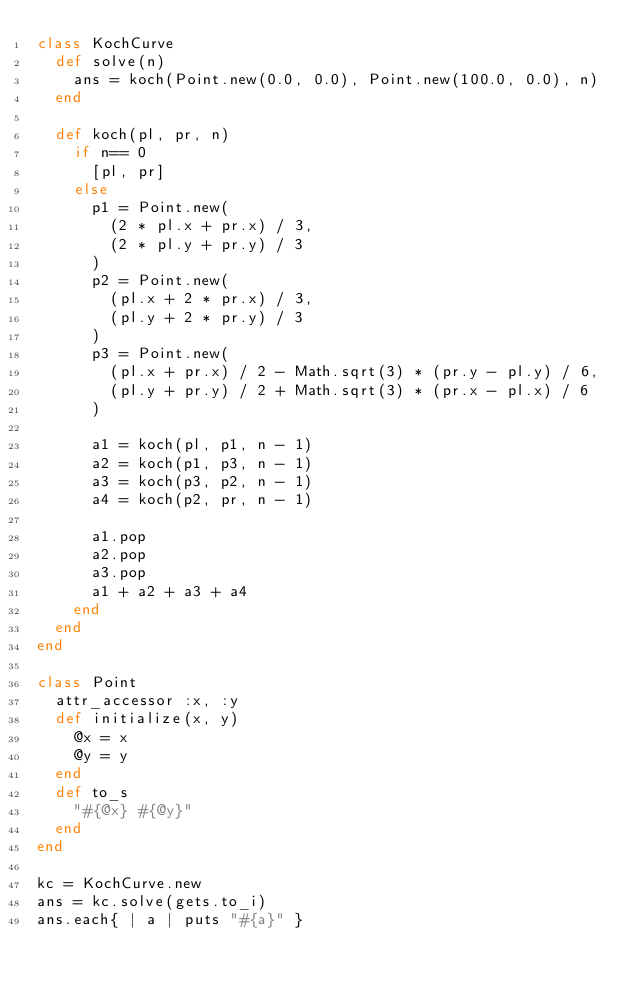Convert code to text. <code><loc_0><loc_0><loc_500><loc_500><_Ruby_>class KochCurve
  def solve(n)
    ans = koch(Point.new(0.0, 0.0), Point.new(100.0, 0.0), n)
  end

  def koch(pl, pr, n)
    if n== 0
      [pl, pr]
    else
      p1 = Point.new(
        (2 * pl.x + pr.x) / 3,
        (2 * pl.y + pr.y) / 3
      )
      p2 = Point.new(
        (pl.x + 2 * pr.x) / 3,
        (pl.y + 2 * pr.y) / 3
      )
      p3 = Point.new(
        (pl.x + pr.x) / 2 - Math.sqrt(3) * (pr.y - pl.y) / 6,
        (pl.y + pr.y) / 2 + Math.sqrt(3) * (pr.x - pl.x) / 6
      )

      a1 = koch(pl, p1, n - 1)
      a2 = koch(p1, p3, n - 1)
      a3 = koch(p3, p2, n - 1)
      a4 = koch(p2, pr, n - 1)

      a1.pop
      a2.pop
      a3.pop
      a1 + a2 + a3 + a4
    end
  end
end

class Point
  attr_accessor :x, :y
  def initialize(x, y)
    @x = x
    @y = y
  end
  def to_s
    "#{@x} #{@y}"
  end
end

kc = KochCurve.new
ans = kc.solve(gets.to_i)
ans.each{ | a | puts "#{a}" }

</code> 